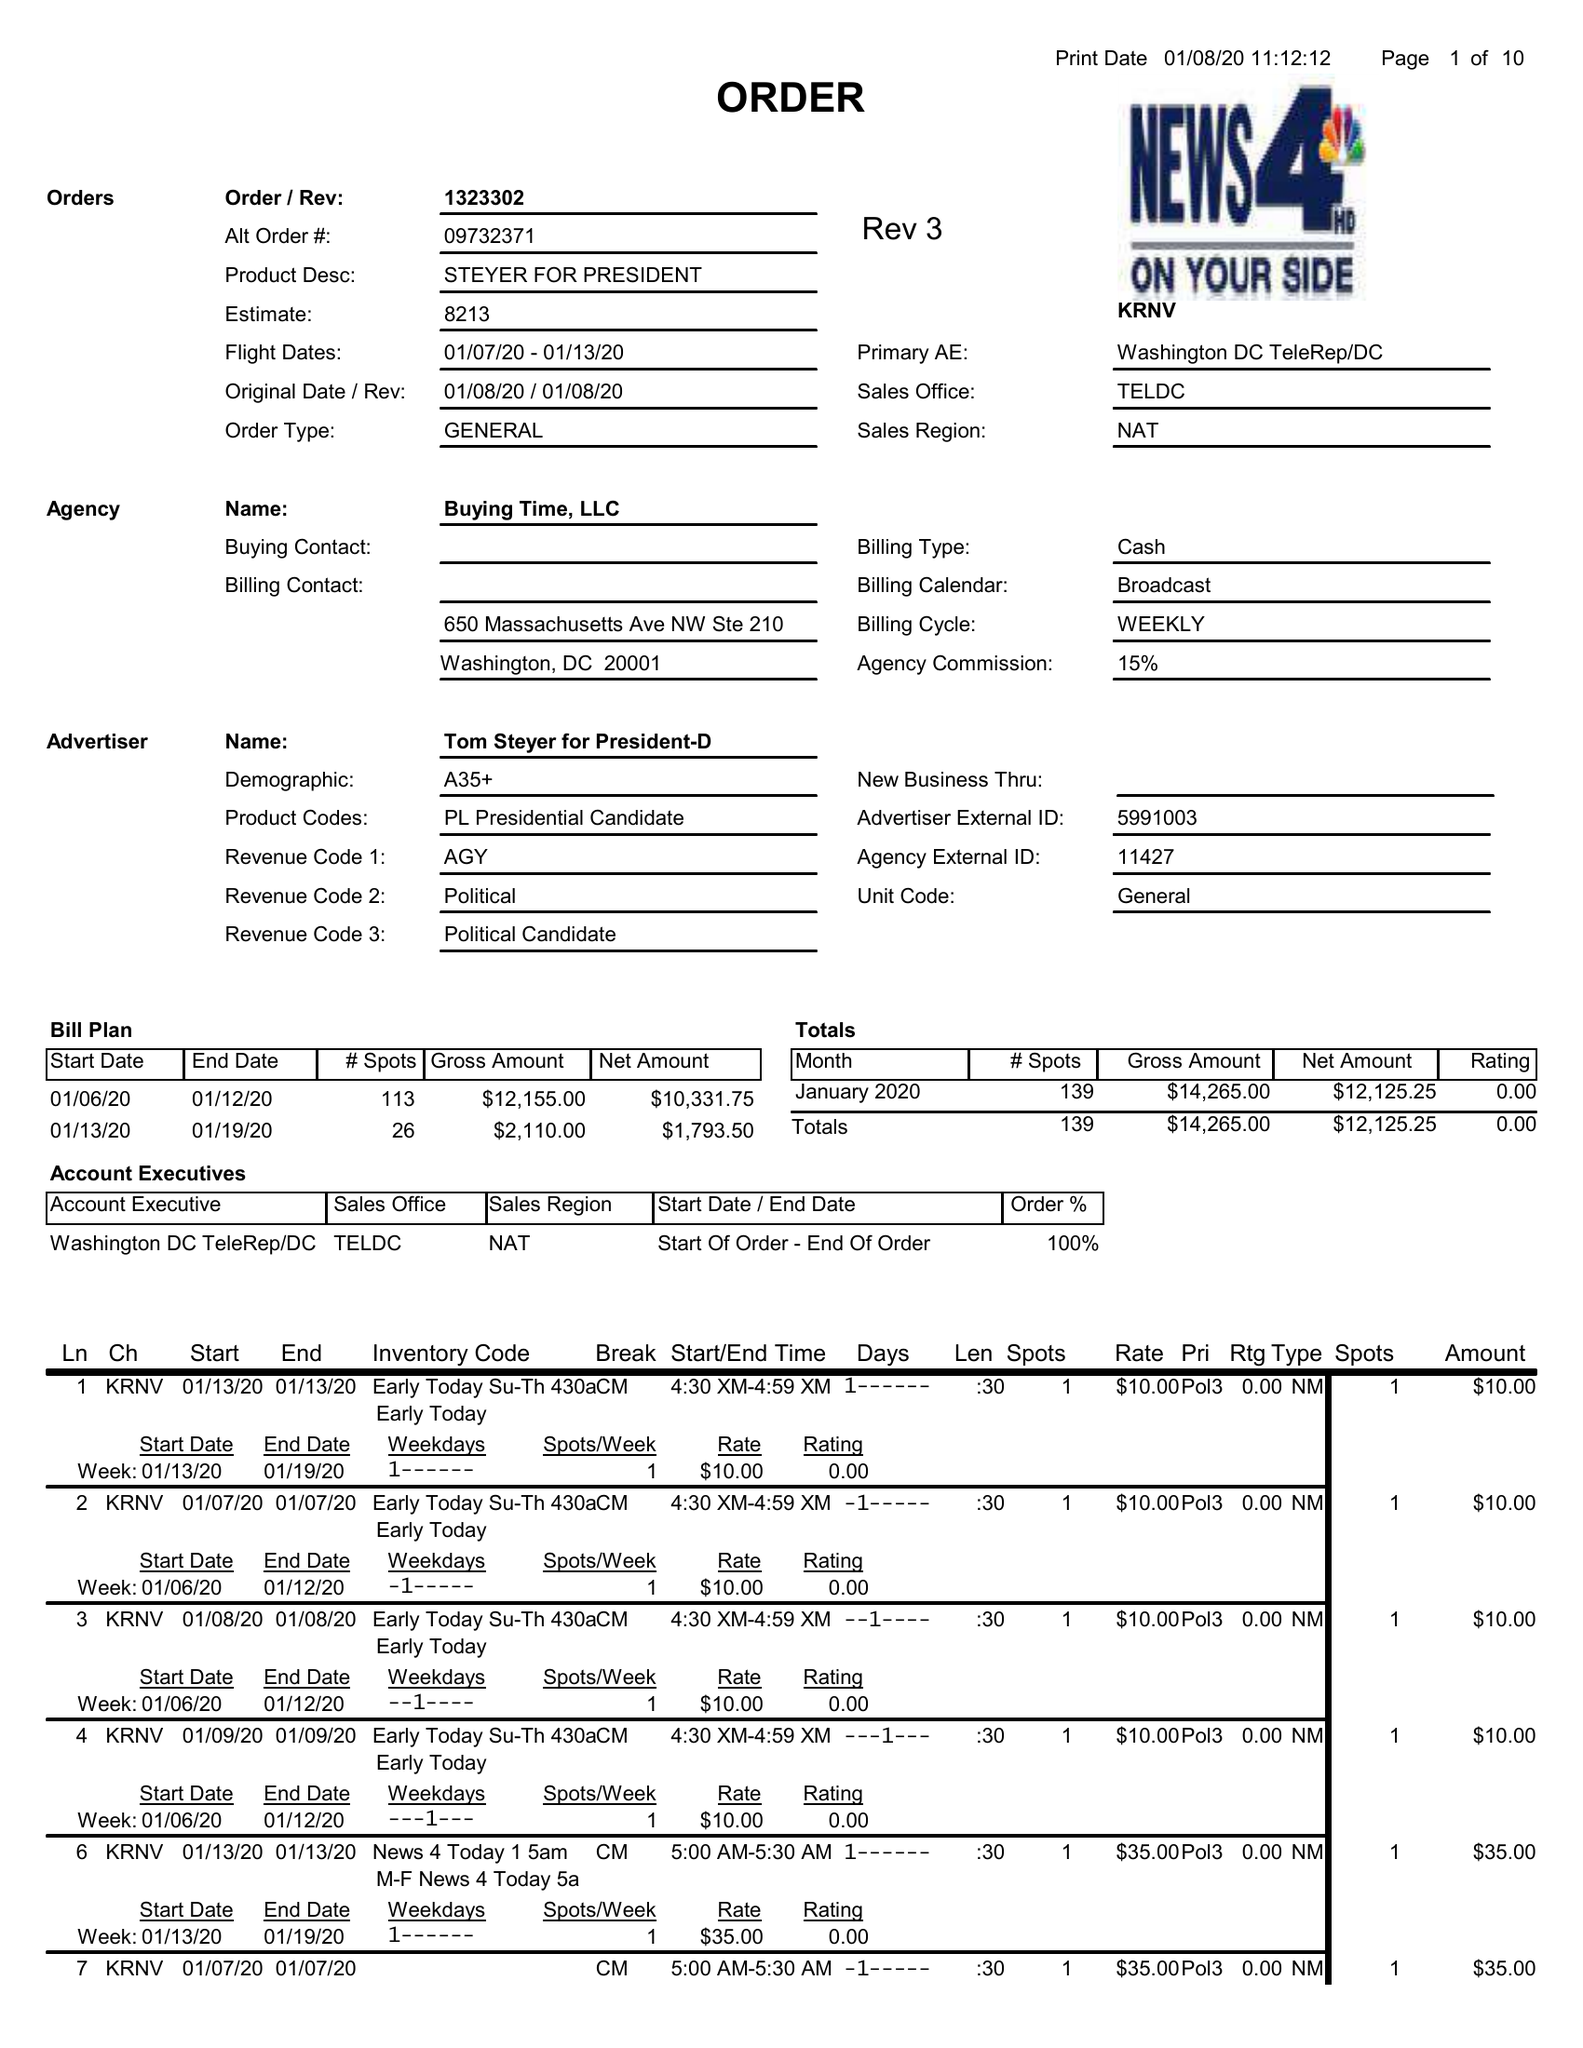What is the value for the contract_num?
Answer the question using a single word or phrase. 1323302 